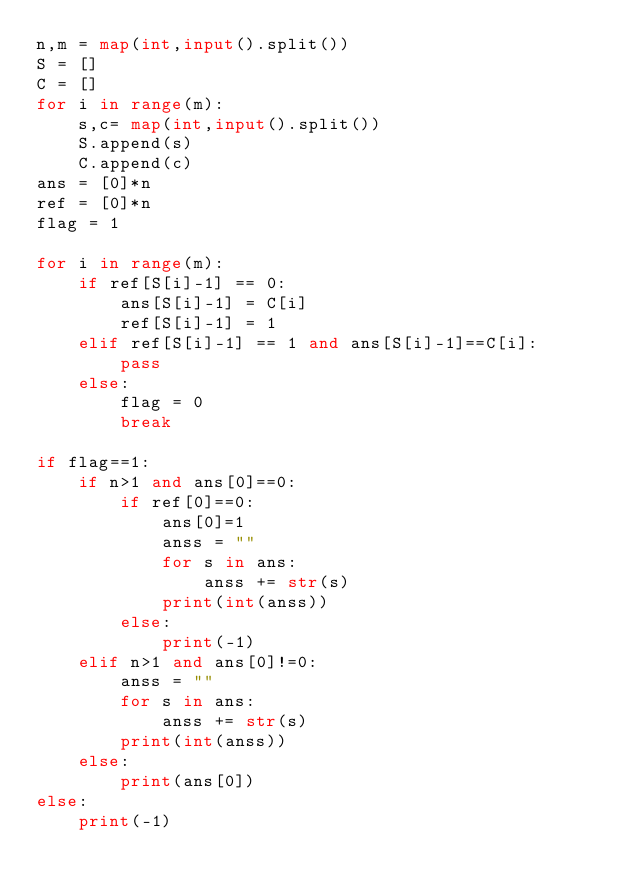<code> <loc_0><loc_0><loc_500><loc_500><_Python_>n,m = map(int,input().split())
S = []
C = []
for i in range(m):
    s,c= map(int,input().split())
    S.append(s)
    C.append(c)
ans = [0]*n
ref = [0]*n
flag = 1

for i in range(m):
    if ref[S[i]-1] == 0:
        ans[S[i]-1] = C[i]
        ref[S[i]-1] = 1
    elif ref[S[i]-1] == 1 and ans[S[i]-1]==C[i]:
        pass
    else:
        flag = 0
        break

if flag==1:
    if n>1 and ans[0]==0:
        if ref[0]==0:
            ans[0]=1
            anss = ""
            for s in ans:
                anss += str(s)
            print(int(anss)) 
        else:
            print(-1)
    elif n>1 and ans[0]!=0:
        anss = ""
        for s in ans:
            anss += str(s)
        print(int(anss))
    else:
        print(ans[0])
else:
    print(-1)
</code> 